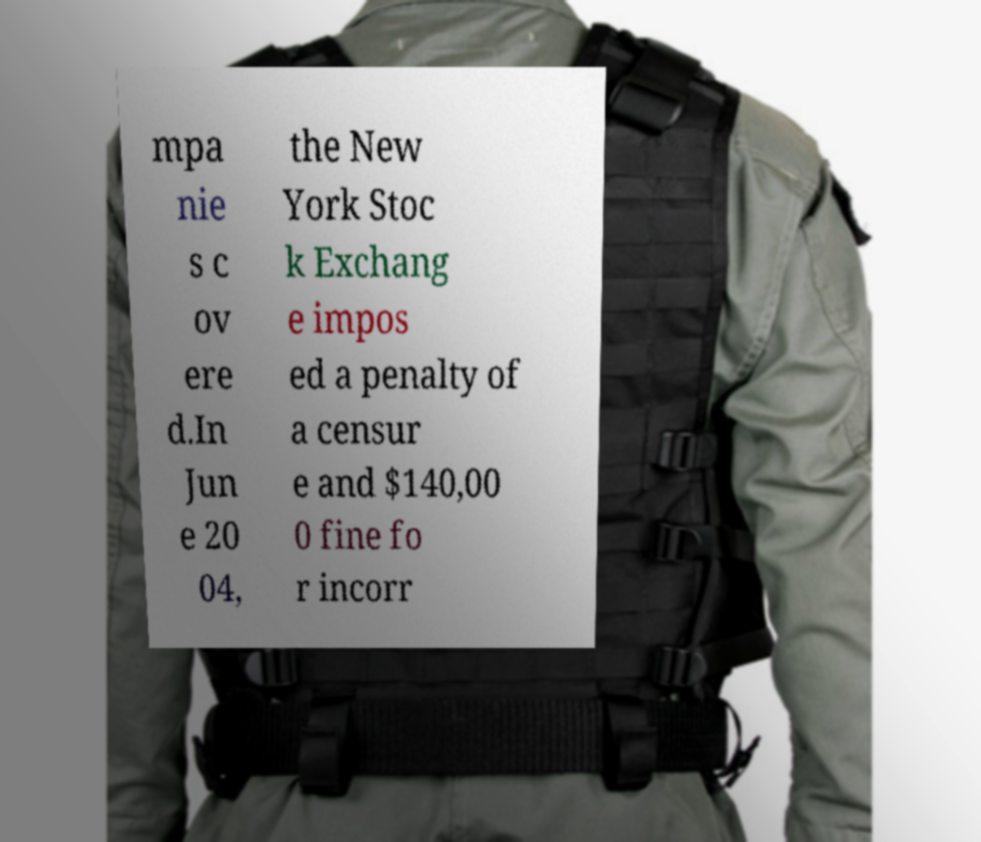There's text embedded in this image that I need extracted. Can you transcribe it verbatim? mpa nie s c ov ere d.In Jun e 20 04, the New York Stoc k Exchang e impos ed a penalty of a censur e and $140,00 0 fine fo r incorr 